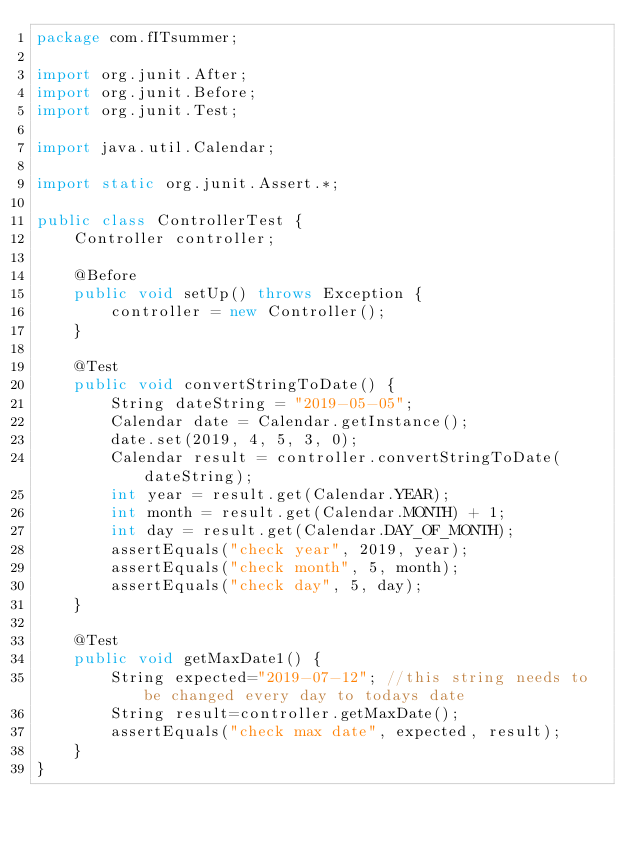Convert code to text. <code><loc_0><loc_0><loc_500><loc_500><_Java_>package com.fITsummer;

import org.junit.After;
import org.junit.Before;
import org.junit.Test;

import java.util.Calendar;

import static org.junit.Assert.*;

public class ControllerTest {
    Controller controller;

    @Before
    public void setUp() throws Exception {
        controller = new Controller();
    }

    @Test
    public void convertStringToDate() {
        String dateString = "2019-05-05";
        Calendar date = Calendar.getInstance();
        date.set(2019, 4, 5, 3, 0);
        Calendar result = controller.convertStringToDate(dateString);
        int year = result.get(Calendar.YEAR);
        int month = result.get(Calendar.MONTH) + 1;
        int day = result.get(Calendar.DAY_OF_MONTH);
        assertEquals("check year", 2019, year);
        assertEquals("check month", 5, month);
        assertEquals("check day", 5, day);
    }

    @Test
    public void getMaxDate1() {
        String expected="2019-07-12"; //this string needs to be changed every day to todays date
        String result=controller.getMaxDate();
        assertEquals("check max date", expected, result);
    }
}</code> 